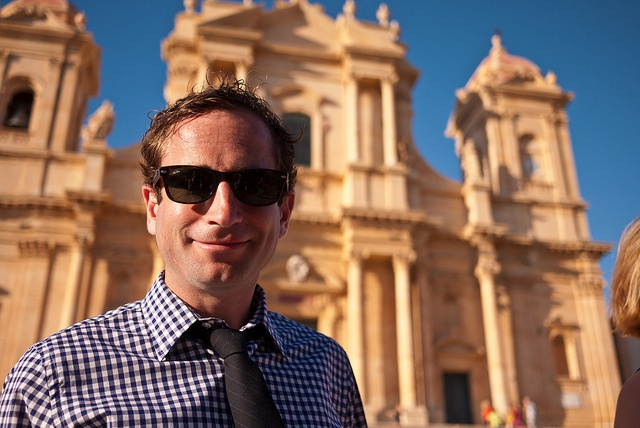Describe the objects in this image and their specific colors. I can see people in blue, black, maroon, purple, and navy tones, tie in blue and black tones, people in blue, maroon, brown, salmon, and tan tones, people in blue, brown, tan, and khaki tones, and people in blue, brown, tan, and maroon tones in this image. 